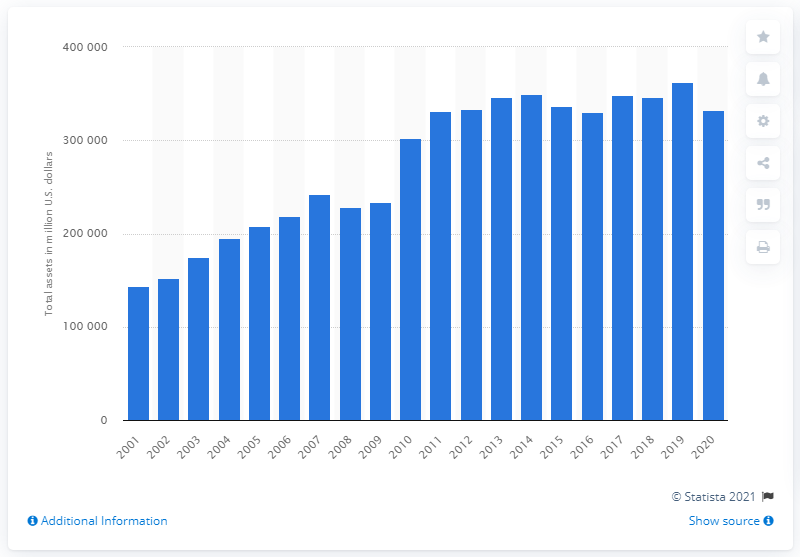Point out several critical features in this image. As of 2020, ExxonMobil's total assets were valued at approximately 332,750 million dollars. 